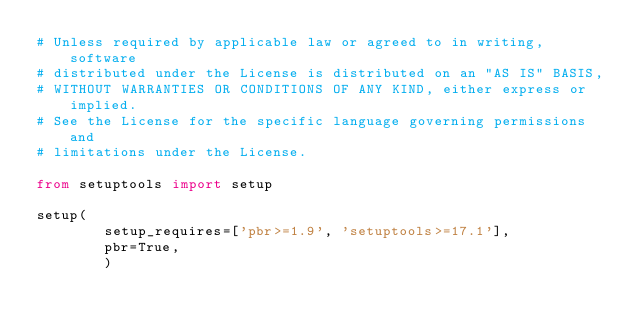<code> <loc_0><loc_0><loc_500><loc_500><_Python_># Unless required by applicable law or agreed to in writing, software
# distributed under the License is distributed on an "AS IS" BASIS,
# WITHOUT WARRANTIES OR CONDITIONS OF ANY KIND, either express or implied.
# See the License for the specific language governing permissions and
# limitations under the License.

from setuptools import setup

setup(
        setup_requires=['pbr>=1.9', 'setuptools>=17.1'],
        pbr=True,
        )

</code> 